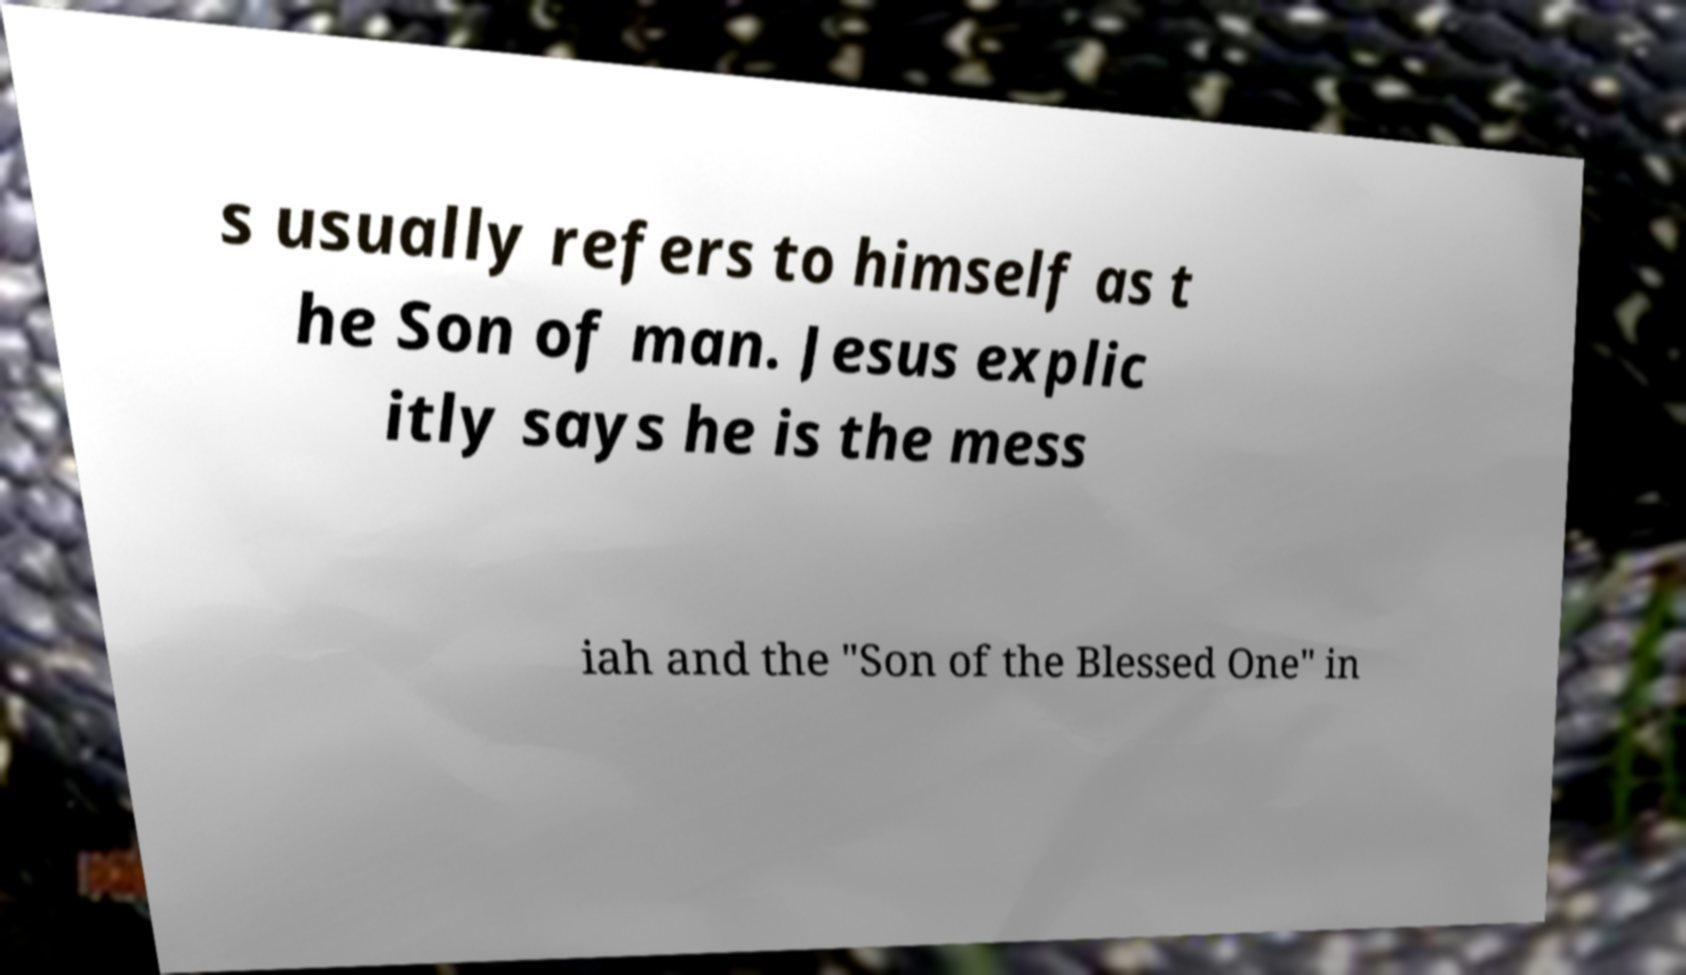Could you assist in decoding the text presented in this image and type it out clearly? s usually refers to himself as t he Son of man. Jesus explic itly says he is the mess iah and the "Son of the Blessed One" in 